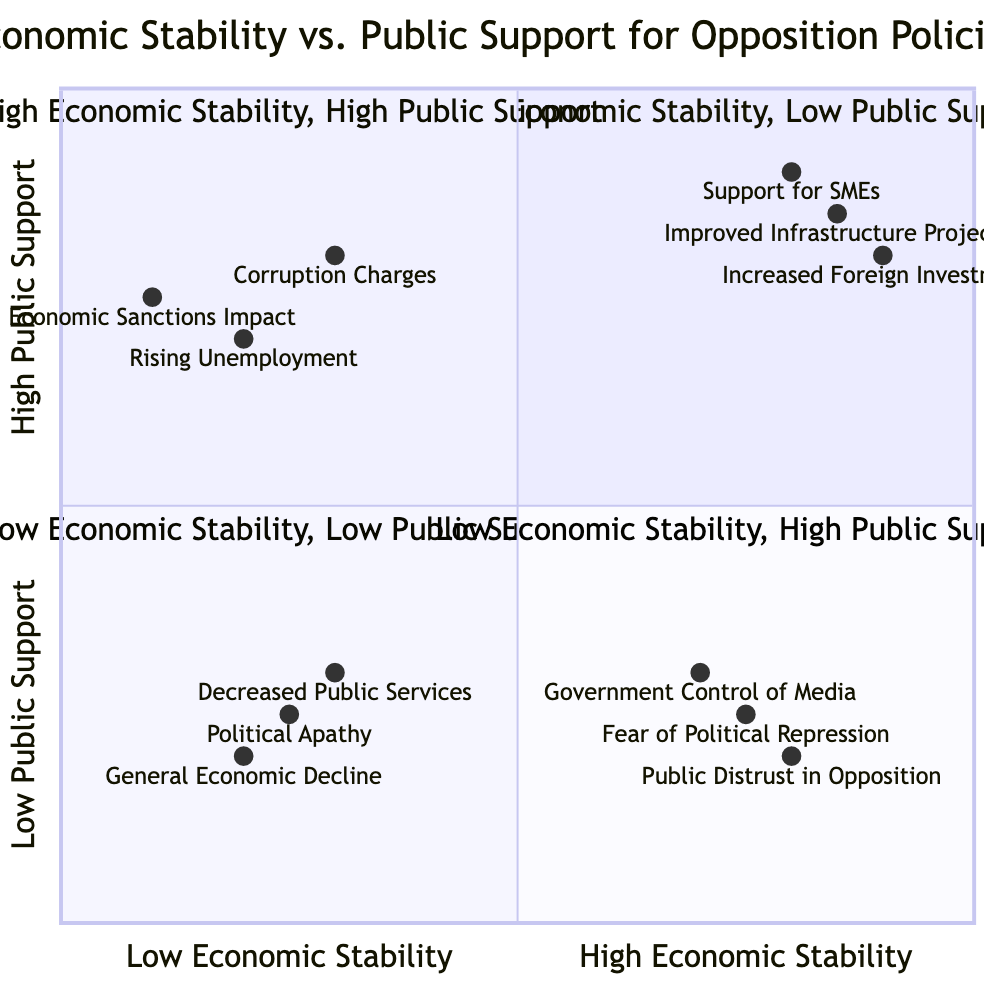What is the element in the top right quadrant? The top right quadrant is labeled "High Economic Stability, High Public Support." The elements in this quadrant include "Increased Foreign Investments," "Improved Infrastructure Projects," and "Support for Small and Medium-sized Enterprises." The specific element mentioned is "Increased Foreign Investments."
Answer: Increased Foreign Investments How many elements are in the bottom left quadrant? The bottom left quadrant, which is labeled "Low Economic Stability, Low Public Support," has three elements: "General Economic Decline," "Decreased Public Services Quality," and "Political Apathy Among Citizens." Therefore, there are three elements in this quadrant.
Answer: 3 Which element corresponds to the highest level of public support in the top left quadrant? In the top left quadrant labeled "High Economic Stability, Low Public Support," the elements are "Government Control of Media," "Public Distrust in Opposition," and "Fear of Political Repression." Among these, "Fear of Political Repression" has the highest public support level as it is positioned higher than the others.
Answer: Fear of Political Repression Is "Rising Unemployment" positioned in the bottom right or bottom left quadrant? "Rising Unemployment" is listed in the bottom right quadrant, which is labeled "Low Economic Stability, High Public Support." Thus, it is located in that specific quadrant rather than the bottom left.
Answer: Bottom right What is the relationship between "Economic Sanctions Impact" and public support? "Economic Sanctions Impact" is in the bottom right quadrant, labeled "Low Economic Stability, High Public Support." This indicates that it corresponds with a situation where there is low economic stability but high public support. Therefore, the relationship is that it represents a challenge where public support remains high despite economic difficulties.
Answer: Low economic stability, high public support Which quadrant features "Support for Small and Medium-sized Enterprises"? "Support for Small and Medium-sized Enterprises" is located in the top right quadrant, which is labeled "High Economic Stability, High Public Support." This positions it within a context of both strong economic conditions and robust public backing.
Answer: Top right What does the location of "Corruption Charges against Officials" suggest about the economic situation? "Corruption Charges against Officials" is placed in the bottom right quadrant, which is labeled "Low Economic Stability, High Public Support." This suggests that even in an environment where public support is strong, the economic situation is challenging due to corruption issues.
Answer: Low economic stability In what quadrant would you find "Decreased Public Services Quality"? "Decreased Public Services Quality" is positioned in the bottom left quadrant, labeled "Low Economic Stability, Low Public Support." This placement signifies a situation where both economic conditions and public support are lacking.
Answer: Bottom left 